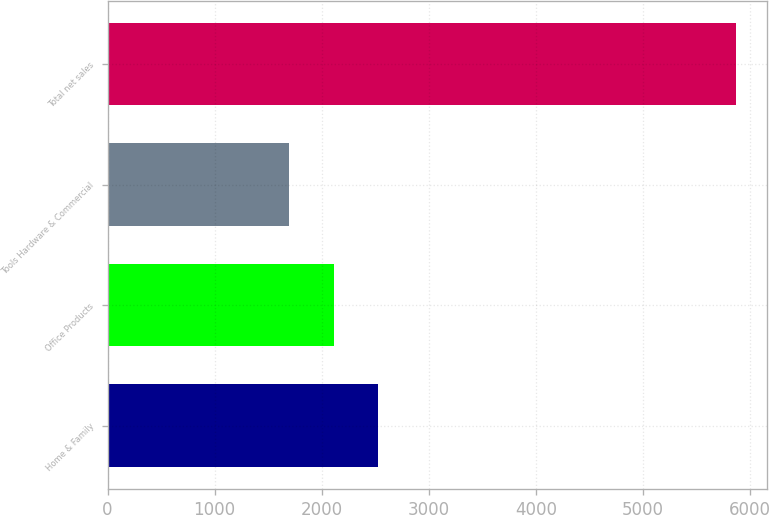<chart> <loc_0><loc_0><loc_500><loc_500><bar_chart><fcel>Home & Family<fcel>Office Products<fcel>Tools Hardware & Commercial<fcel>Total net sales<nl><fcel>2529.16<fcel>2112.23<fcel>1695.3<fcel>5864.6<nl></chart> 